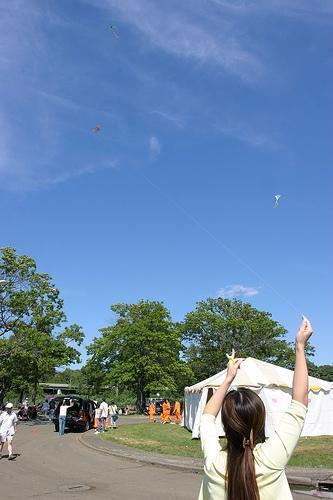How many vehicles are visible?
Give a very brief answer. 1. How many kites are shown in the sky?
Give a very brief answer. 3. How many animals are pictured?
Give a very brief answer. 0. How many people are wearing orange jumpsuits?
Give a very brief answer. 3. 